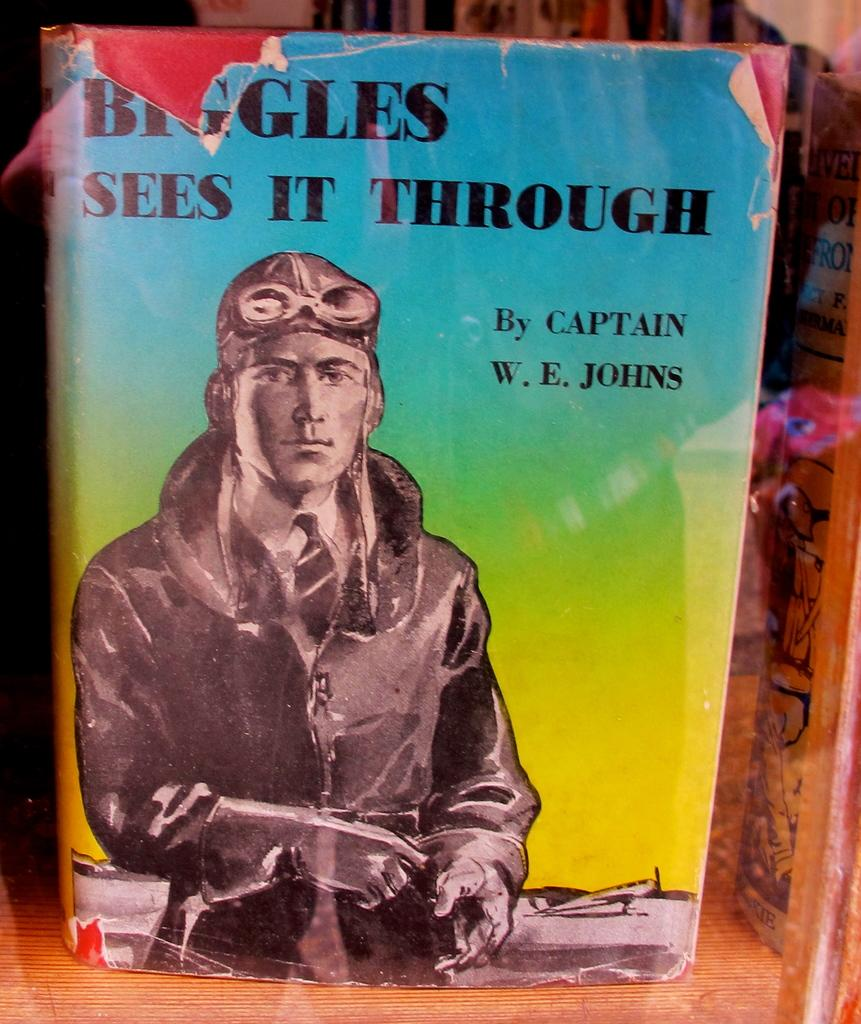<image>
Present a compact description of the photo's key features. A book by Captain W. E. Johns entitled Biggles Sees It Through 